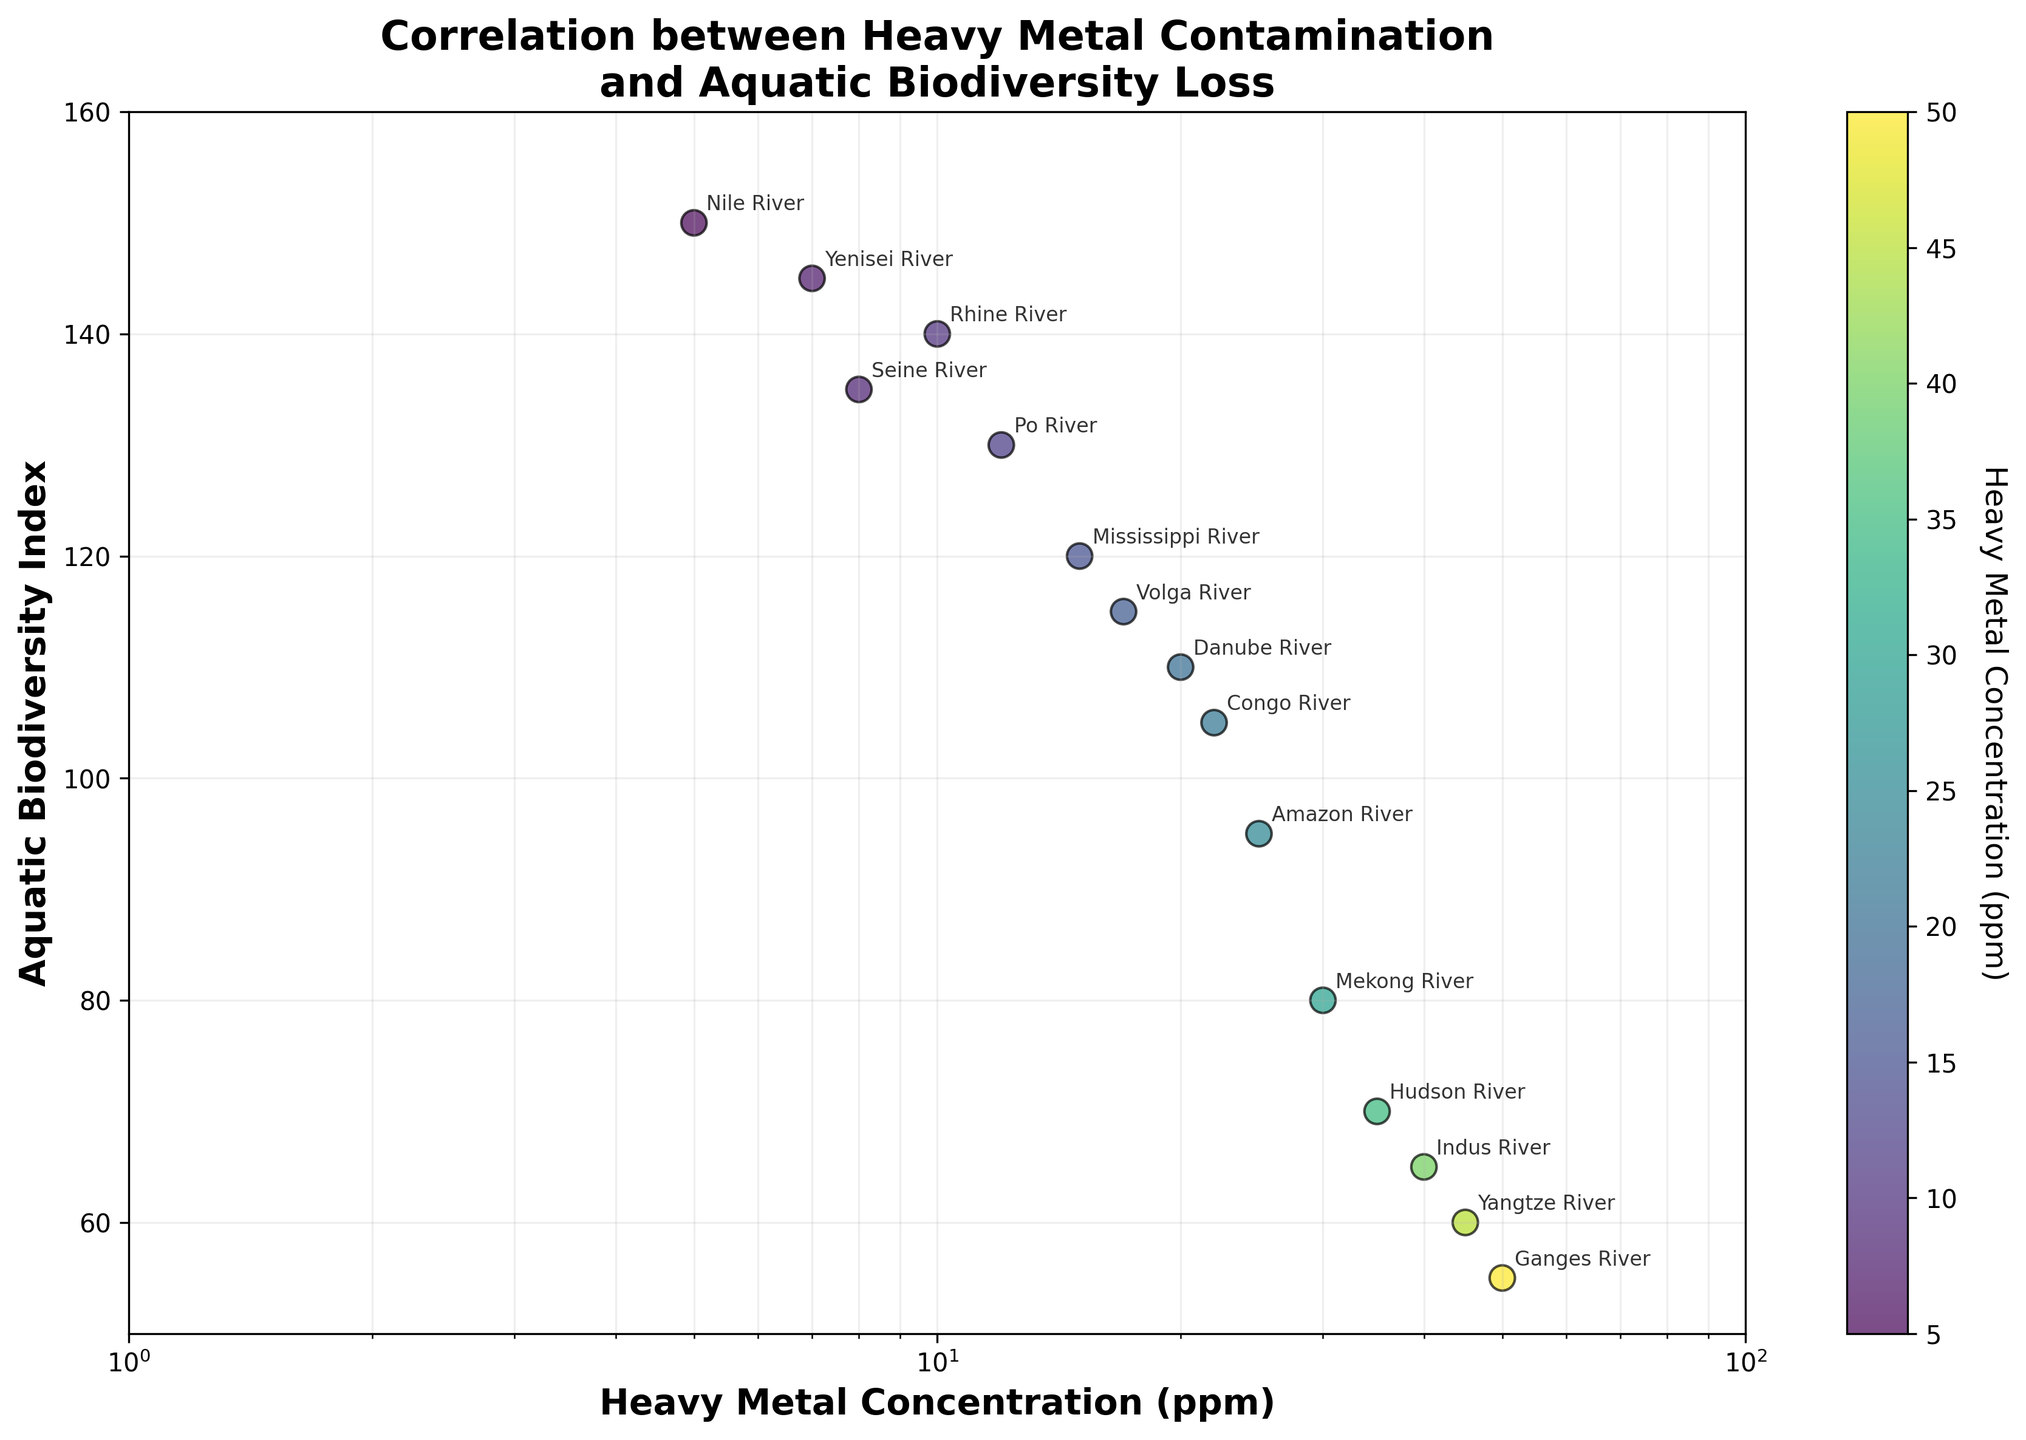What is the title of the plot? The title of the plot is located at the top of the figure and it reads: 'Correlation between Heavy Metal Contamination and Aquatic Biodiversity Loss'.
Answer: Correlation between Heavy Metal Contamination and Aquatic Biodiversity Loss What do the x and y axes represent? The x-axis represents 'Heavy Metal Concentration (ppm)' and the y-axis represents 'Aquatic Biodiversity Index'. This is indicated by the labels next to the axes.
Answer: Heavy Metal Concentration (ppm) and Aquatic Biodiversity Index Which river system has the highest heavy metal concentration? By examining the scatter plot, the point with the highest x-value (farthest to the right) corresponds to the Ganges River with a heavy metal concentration of 50 ppm.
Answer: Ganges River Which river system has the highest aquatic biodiversity index? The point with the highest y-value (near the top of the plot) corresponds to the Nile River, indicating the highest aquatic biodiversity index of 150.
Answer: Nile River How many river systems have a heavy metal concentration below 10 ppm? By visually identifying the points on the scatter plot to the left of the 10 ppm mark on the log scale x-axis, there are 2 river systems: Nile River (5 ppm) and Yenisei River (7 ppm).
Answer: 2 Which river systems have a heavy metal concentration between 20 and 30 ppm? By examining the scatter plot within the range of 20 and 30 ppm on the x-axis, the river systems are Danube River (20 ppm), Amazon River (25 ppm), and Mekong River (30 ppm).
Answer: Danube River, Amazon River, Mekong River Is there a general trend between heavy metal concentration and aquatic biodiversity index? From the scatter plot, there appears to be a negative correlation, where increasing heavy metal concentration is associated with a decrease in the aquatic biodiversity index.
Answer: Negative correlation Which river system has the closest aquatic biodiversity index to 100? By observing the scatter plot, the Congo River has an aquatic biodiversity index closest to 100, which is estimated to be around 105.
Answer: Congo River Which river systems have an aquatic biodiversity index higher than 130? By checking the points above the 130 mark on the y-axis, the river systems are: Nile River, Yenisei River, Seine River, and Rhine River.
Answer: Nile River, Yenisei River, Seine River, Rhine River What is the approximate change in aquatic biodiversity index from the Mississippi River to the Hudson River? The aquatic biodiversity index of the Mississippi River is 120, and the Hudson River is 70. The approximate change is 120 - 70 = 50.
Answer: 50 